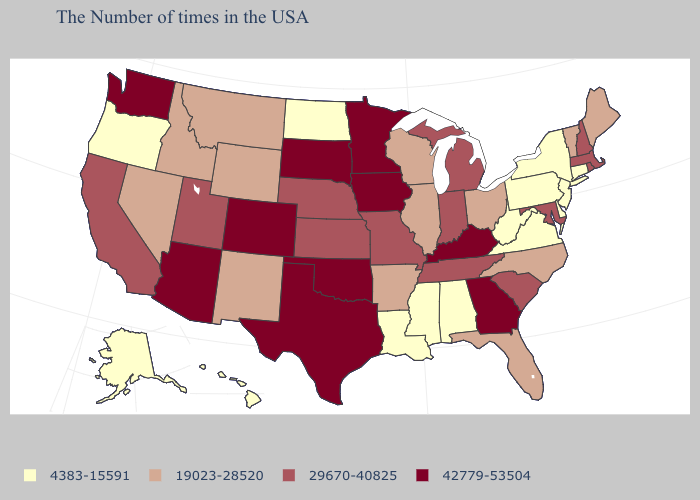Name the states that have a value in the range 19023-28520?
Concise answer only. Maine, Vermont, North Carolina, Ohio, Florida, Wisconsin, Illinois, Arkansas, Wyoming, New Mexico, Montana, Idaho, Nevada. Does South Dakota have the same value as Pennsylvania?
Short answer required. No. Does Maryland have a lower value than Washington?
Concise answer only. Yes. What is the value of Georgia?
Answer briefly. 42779-53504. What is the value of Hawaii?
Answer briefly. 4383-15591. Does Kentucky have the highest value in the USA?
Give a very brief answer. Yes. What is the lowest value in the South?
Give a very brief answer. 4383-15591. What is the value of Indiana?
Write a very short answer. 29670-40825. How many symbols are there in the legend?
Write a very short answer. 4. Does Florida have the highest value in the USA?
Write a very short answer. No. Name the states that have a value in the range 42779-53504?
Short answer required. Georgia, Kentucky, Minnesota, Iowa, Oklahoma, Texas, South Dakota, Colorado, Arizona, Washington. Name the states that have a value in the range 42779-53504?
Give a very brief answer. Georgia, Kentucky, Minnesota, Iowa, Oklahoma, Texas, South Dakota, Colorado, Arizona, Washington. Does New Hampshire have the highest value in the Northeast?
Answer briefly. Yes. Name the states that have a value in the range 4383-15591?
Quick response, please. Connecticut, New York, New Jersey, Delaware, Pennsylvania, Virginia, West Virginia, Alabama, Mississippi, Louisiana, North Dakota, Oregon, Alaska, Hawaii. 